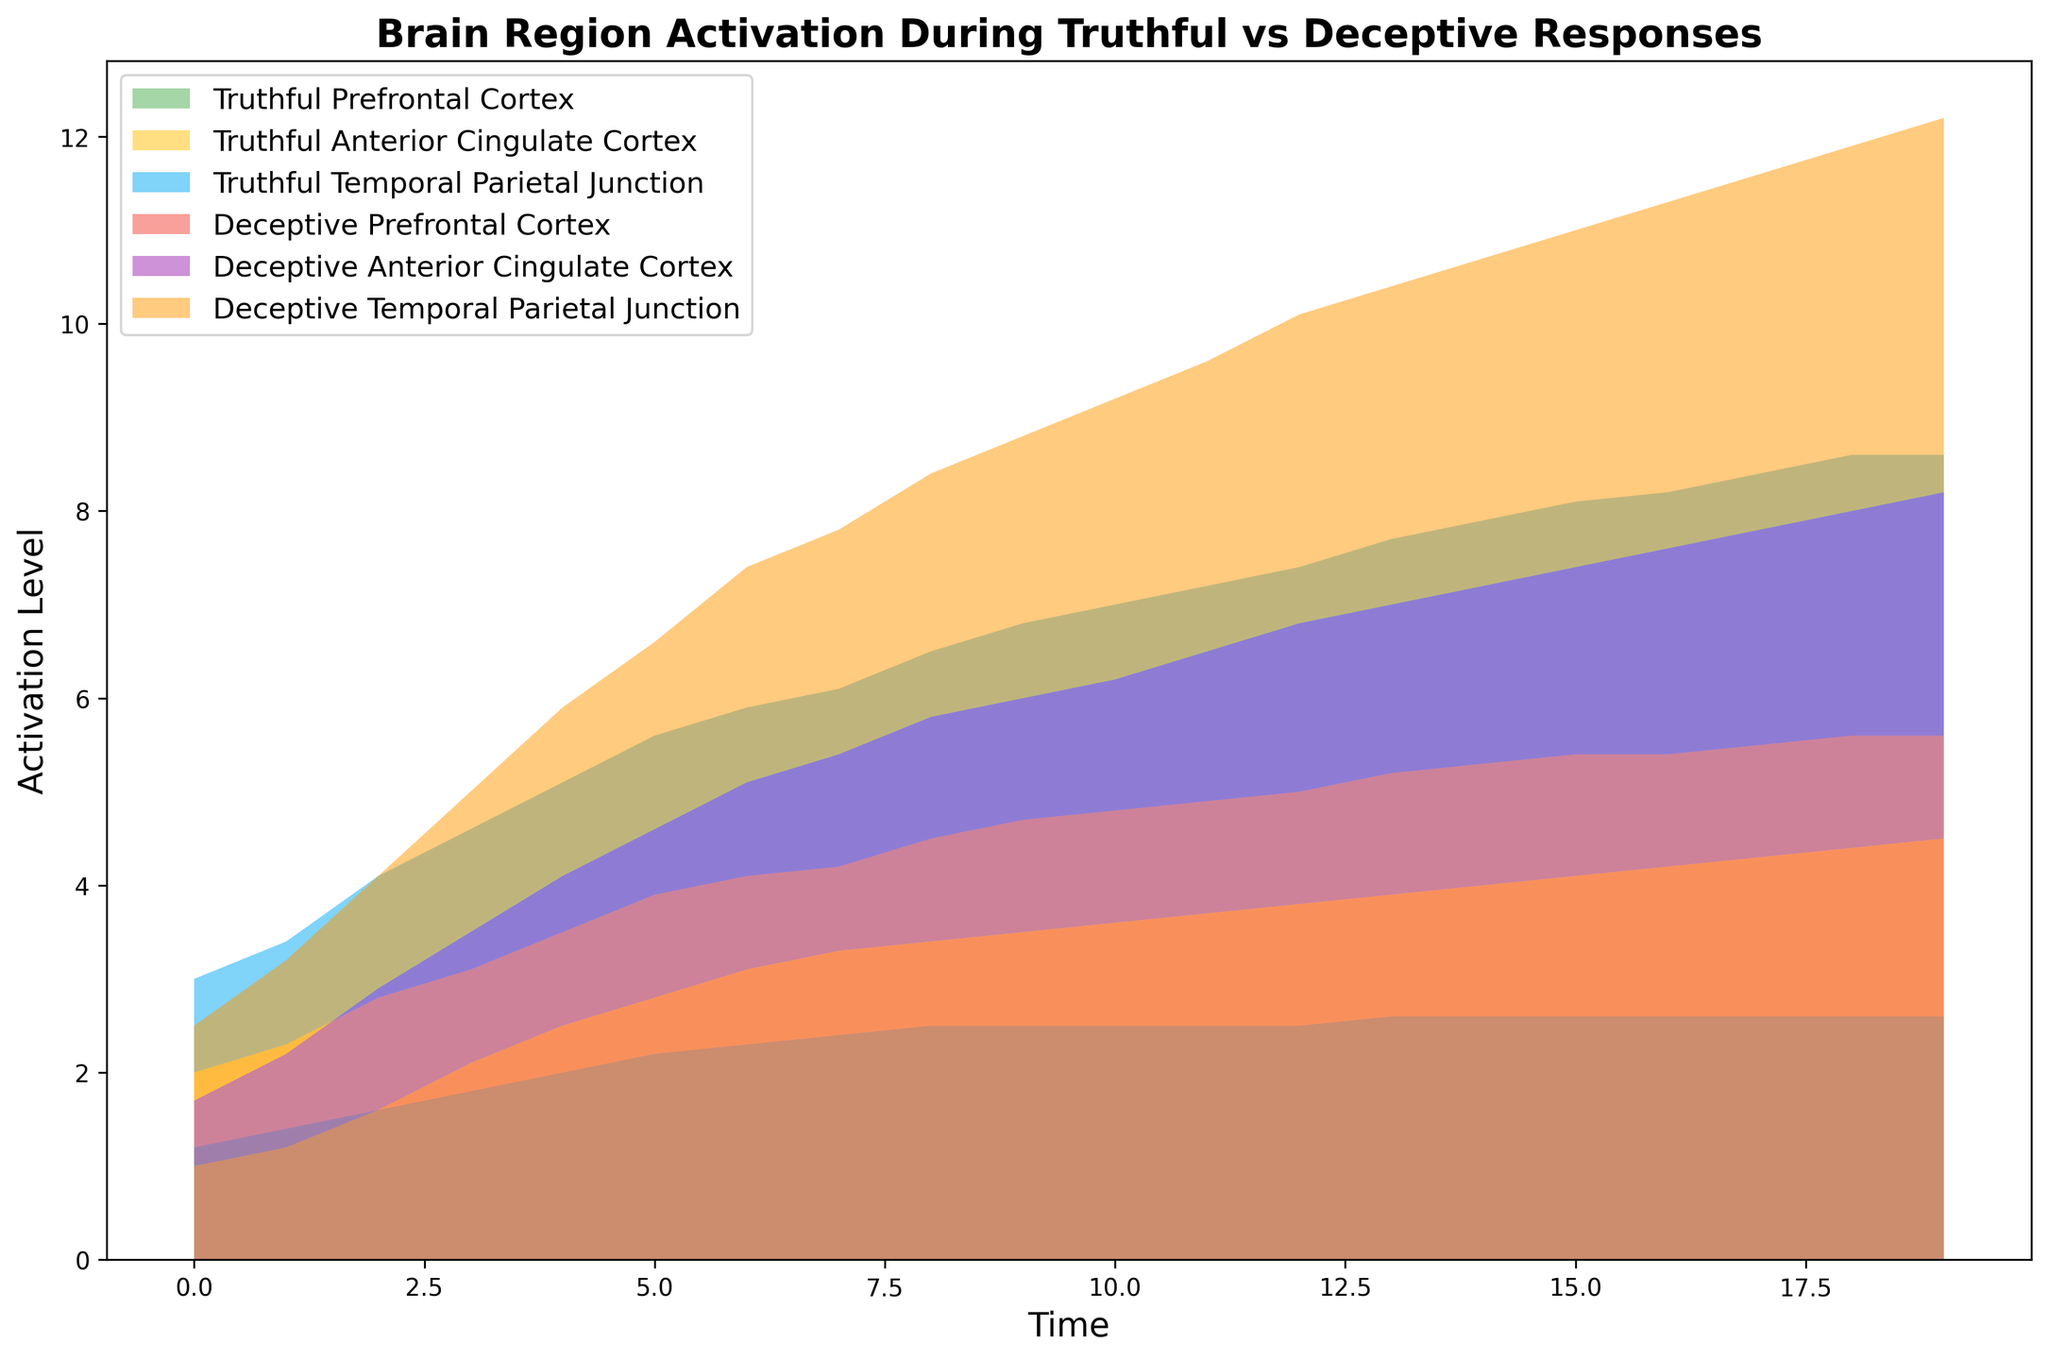What time does the Deceptive Prefrontal Cortex show an activation level of 3.1? The area chart shows the activation levels across different time points. By locating "Deceptive Prefrontal Cortex" and finding the point where its activation reaches 3.1, we see that this occurs at time = 6
Answer: 6 How does the activation level of the Truthful Temporal Parietal Junction compare to the Deceptive Temporal Parietal Junction at time = 10? At time = 10, the activation level for the Truthful Temporal Parietal Junction is 2.2, while for the Deceptive Temporal Parietal Junction it is 3.0. Hence, the Deceptive Temporal Parietal Junction has a higher activation level.
Answer: Deceptive Temporal Parietal Junction is higher Between the Truthful and Deceptive conditions, which brain region shows the greatest increase in activation from time = 0 to time = 19? We need to calculate the activation level difference at time = 0 and time = 19 for both conditions. For the Deceptive Prefrontal Cortex: 4.5 - 1.0 = 3.5. For the Truthful Prefrontal Cortex: 2.6 - 1.2 = 1.4. Comparing increases for the Anterior Cingulate Cortex and the Temporal Parietal Junction, the Deceptive Prefrontal Cortex shows the greatest increase.
Answer: Deceptive Prefrontal Cortex What is the average activation level of the Truthful Anterior Cingulate Cortex and the Deceptive Anterior Cingulate Cortex at time = 10? The activation levels are: Truthful Anterior Cingulate Cortex = 2.3, and Deceptive Anterior Cingulate Cortex = 2.6. Average = (2.3 + 2.6) / 2 = 2.45.
Answer: 2.45 At time = 10, is the activation level of the Truthful Prefrontal Cortex equal to the activation level of the Deceptive Prefrontal Cortex at time = 7? The activation level of the Truthful Prefrontal Cortex at time = 10 is 2.5. At time = 7, the Deceptive Prefrontal Cortex activation level is 3.3. These levels are not equal.
Answer: No Which brain region has a higher activation level, Truthful Anterior Cingulate Cortex or Deceptive Anterior Cingulate Cortex, at time = 15? At time = 15, the activation level for the Truthful Anterior Cingulate Cortex is 2.8, while for the Deceptive Anterior Cingulate Cortex it is 3.3. Therefore, the Deceptive Anterior Cingulate Cortex has a higher activation level.
Answer: Deceptive Anterior Cingulate Cortex Summarize the overall trend of activation levels for the Deceptive Temporal Parietal Junction. The activation level of the Deceptive Temporal Parietal Junction shows an increasing trend over time, starting at 0.8 and reaching 4.0 by time = 19.
Answer: Increasing For which time points does the Truthful Prefrontal Cortex have an activation level greater than or equal to 2.5? By inspecting the chart, the Truthful Prefrontal Cortex activation levels are 2.5 or higher from time = 9 to time = 19.
Answer: 9 to 19 During which time interval is the difference between the Deceptive and Truthful Prefrontal Cortex activation levels the largest? To find the largest difference between Deceptive and Truthful Prefrontal Cortex activation levels, we need to inspect the chart between time points and compare the differences. The largest difference is at time = 19, where it is 4.5 - 2.6 = 1.9.
Answer: At time = 19 How does the activation level of the Truthful Prefrontal Cortex change between time = 0 and time = 10? At time = 0, the Truthful Prefrontal Cortex has an activation level of 1.2; at time = 10, it is 2.5. The change is an increase of 2.5 - 1.2 = 1.3.
Answer: Increase by 1.3 